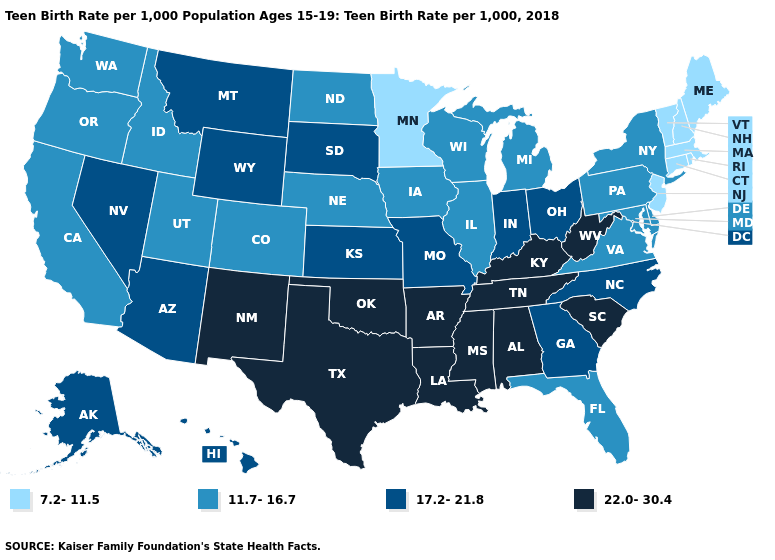Does Nebraska have the highest value in the MidWest?
Short answer required. No. Among the states that border Alabama , does Tennessee have the highest value?
Keep it brief. Yes. What is the value of Alaska?
Give a very brief answer. 17.2-21.8. Name the states that have a value in the range 17.2-21.8?
Write a very short answer. Alaska, Arizona, Georgia, Hawaii, Indiana, Kansas, Missouri, Montana, Nevada, North Carolina, Ohio, South Dakota, Wyoming. Does Mississippi have the highest value in the USA?
Short answer required. Yes. What is the lowest value in states that border Kansas?
Give a very brief answer. 11.7-16.7. Does the first symbol in the legend represent the smallest category?
Concise answer only. Yes. Does the map have missing data?
Keep it brief. No. Does Delaware have the highest value in the USA?
Answer briefly. No. Name the states that have a value in the range 7.2-11.5?
Concise answer only. Connecticut, Maine, Massachusetts, Minnesota, New Hampshire, New Jersey, Rhode Island, Vermont. Does Montana have the same value as New York?
Concise answer only. No. What is the value of Iowa?
Write a very short answer. 11.7-16.7. Among the states that border Kansas , which have the highest value?
Write a very short answer. Oklahoma. Name the states that have a value in the range 17.2-21.8?
Keep it brief. Alaska, Arizona, Georgia, Hawaii, Indiana, Kansas, Missouri, Montana, Nevada, North Carolina, Ohio, South Dakota, Wyoming. Does Wyoming have a higher value than Louisiana?
Quick response, please. No. 